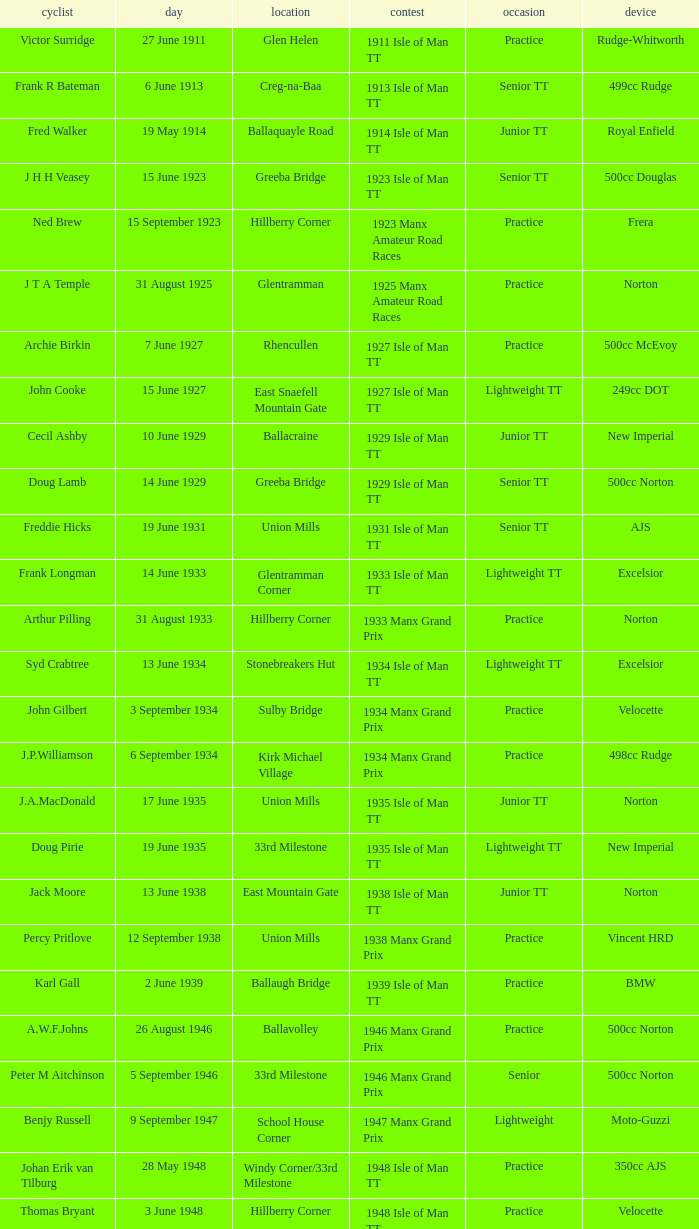What machine did Keith T. Gawler ride? 499cc Norton. 